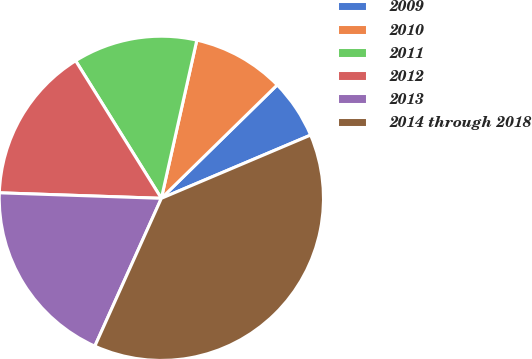<chart> <loc_0><loc_0><loc_500><loc_500><pie_chart><fcel>2009<fcel>2010<fcel>2011<fcel>2012<fcel>2013<fcel>2014 through 2018<nl><fcel>5.95%<fcel>9.16%<fcel>12.38%<fcel>15.59%<fcel>18.81%<fcel>38.11%<nl></chart> 